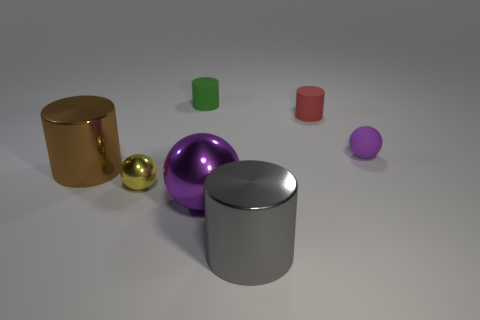How would you describe the sizes of these objects relative to one another? The objects vary in size, with the cylinders and the purple sphere being the largest elements, while the gold and yellow spheres are considerably smaller, creating a contrast in scale that adds interest to the scene. 